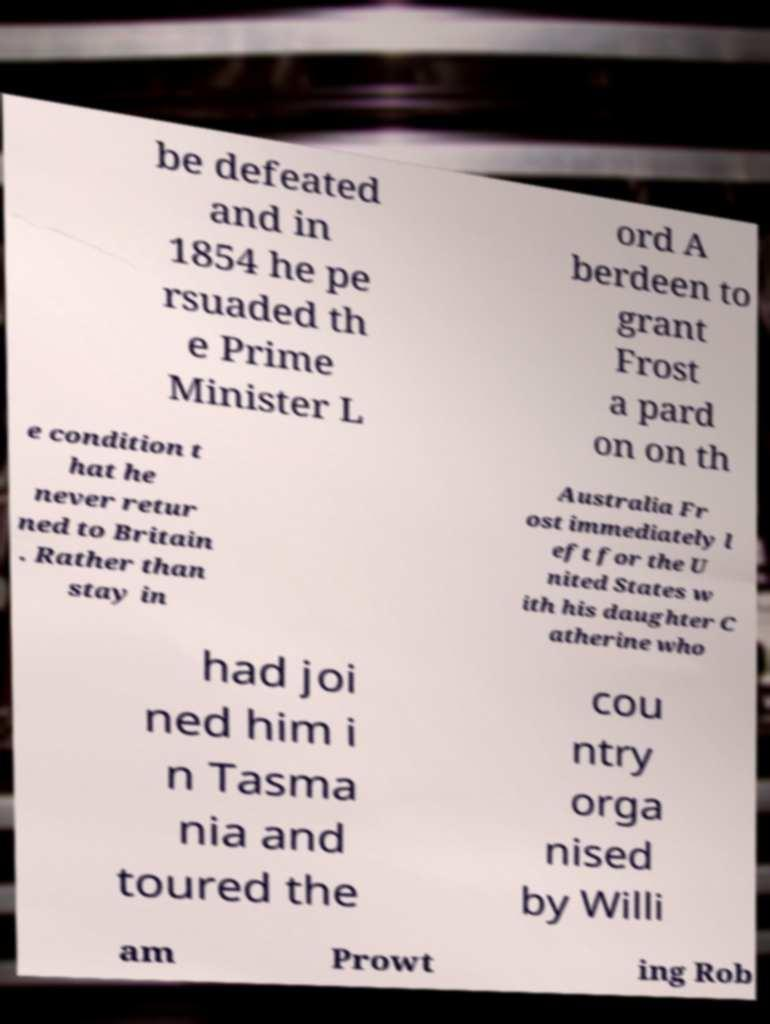What messages or text are displayed in this image? I need them in a readable, typed format. be defeated and in 1854 he pe rsuaded th e Prime Minister L ord A berdeen to grant Frost a pard on on th e condition t hat he never retur ned to Britain . Rather than stay in Australia Fr ost immediately l eft for the U nited States w ith his daughter C atherine who had joi ned him i n Tasma nia and toured the cou ntry orga nised by Willi am Prowt ing Rob 